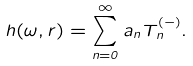<formula> <loc_0><loc_0><loc_500><loc_500>h ( \omega , r ) = \sum _ { n = 0 } ^ { \infty } a _ { n } T _ { n } ^ { ( - ) } .</formula> 